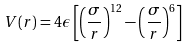Convert formula to latex. <formula><loc_0><loc_0><loc_500><loc_500>V ( r ) = 4 \epsilon \left [ \left ( \frac { \sigma } { r } \right ) ^ { 1 2 } - \left ( \frac { \sigma } { r } \right ) ^ { 6 } \right ]</formula> 